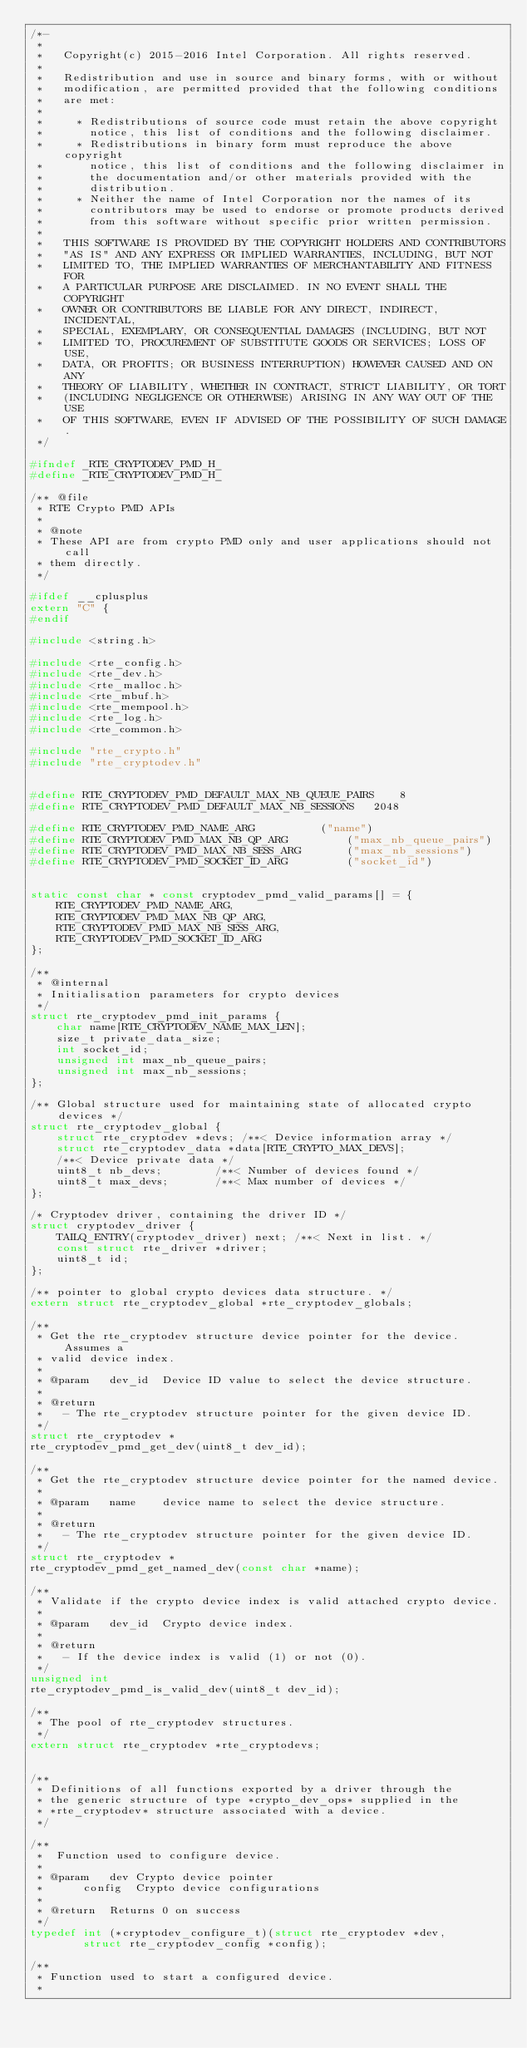Convert code to text. <code><loc_0><loc_0><loc_500><loc_500><_C_>/*-
 *
 *   Copyright(c) 2015-2016 Intel Corporation. All rights reserved.
 *
 *   Redistribution and use in source and binary forms, with or without
 *   modification, are permitted provided that the following conditions
 *   are met:
 *
 *     * Redistributions of source code must retain the above copyright
 *       notice, this list of conditions and the following disclaimer.
 *     * Redistributions in binary form must reproduce the above copyright
 *       notice, this list of conditions and the following disclaimer in
 *       the documentation and/or other materials provided with the
 *       distribution.
 *     * Neither the name of Intel Corporation nor the names of its
 *       contributors may be used to endorse or promote products derived
 *       from this software without specific prior written permission.
 *
 *   THIS SOFTWARE IS PROVIDED BY THE COPYRIGHT HOLDERS AND CONTRIBUTORS
 *   "AS IS" AND ANY EXPRESS OR IMPLIED WARRANTIES, INCLUDING, BUT NOT
 *   LIMITED TO, THE IMPLIED WARRANTIES OF MERCHANTABILITY AND FITNESS FOR
 *   A PARTICULAR PURPOSE ARE DISCLAIMED. IN NO EVENT SHALL THE COPYRIGHT
 *   OWNER OR CONTRIBUTORS BE LIABLE FOR ANY DIRECT, INDIRECT, INCIDENTAL,
 *   SPECIAL, EXEMPLARY, OR CONSEQUENTIAL DAMAGES (INCLUDING, BUT NOT
 *   LIMITED TO, PROCUREMENT OF SUBSTITUTE GOODS OR SERVICES; LOSS OF USE,
 *   DATA, OR PROFITS; OR BUSINESS INTERRUPTION) HOWEVER CAUSED AND ON ANY
 *   THEORY OF LIABILITY, WHETHER IN CONTRACT, STRICT LIABILITY, OR TORT
 *   (INCLUDING NEGLIGENCE OR OTHERWISE) ARISING IN ANY WAY OUT OF THE USE
 *   OF THIS SOFTWARE, EVEN IF ADVISED OF THE POSSIBILITY OF SUCH DAMAGE.
 */

#ifndef _RTE_CRYPTODEV_PMD_H_
#define _RTE_CRYPTODEV_PMD_H_

/** @file
 * RTE Crypto PMD APIs
 *
 * @note
 * These API are from crypto PMD only and user applications should not call
 * them directly.
 */

#ifdef __cplusplus
extern "C" {
#endif

#include <string.h>

#include <rte_config.h>
#include <rte_dev.h>
#include <rte_malloc.h>
#include <rte_mbuf.h>
#include <rte_mempool.h>
#include <rte_log.h>
#include <rte_common.h>

#include "rte_crypto.h"
#include "rte_cryptodev.h"


#define RTE_CRYPTODEV_PMD_DEFAULT_MAX_NB_QUEUE_PAIRS	8
#define RTE_CRYPTODEV_PMD_DEFAULT_MAX_NB_SESSIONS	2048

#define RTE_CRYPTODEV_PMD_NAME_ARG			("name")
#define RTE_CRYPTODEV_PMD_MAX_NB_QP_ARG			("max_nb_queue_pairs")
#define RTE_CRYPTODEV_PMD_MAX_NB_SESS_ARG		("max_nb_sessions")
#define RTE_CRYPTODEV_PMD_SOCKET_ID_ARG			("socket_id")


static const char * const cryptodev_pmd_valid_params[] = {
	RTE_CRYPTODEV_PMD_NAME_ARG,
	RTE_CRYPTODEV_PMD_MAX_NB_QP_ARG,
	RTE_CRYPTODEV_PMD_MAX_NB_SESS_ARG,
	RTE_CRYPTODEV_PMD_SOCKET_ID_ARG
};

/**
 * @internal
 * Initialisation parameters for crypto devices
 */
struct rte_cryptodev_pmd_init_params {
	char name[RTE_CRYPTODEV_NAME_MAX_LEN];
	size_t private_data_size;
	int socket_id;
	unsigned int max_nb_queue_pairs;
	unsigned int max_nb_sessions;
};

/** Global structure used for maintaining state of allocated crypto devices */
struct rte_cryptodev_global {
	struct rte_cryptodev *devs;	/**< Device information array */
	struct rte_cryptodev_data *data[RTE_CRYPTO_MAX_DEVS];
	/**< Device private data */
	uint8_t nb_devs;		/**< Number of devices found */
	uint8_t max_devs;		/**< Max number of devices */
};

/* Cryptodev driver, containing the driver ID */
struct cryptodev_driver {
	TAILQ_ENTRY(cryptodev_driver) next; /**< Next in list. */
	const struct rte_driver *driver;
	uint8_t id;
};

/** pointer to global crypto devices data structure. */
extern struct rte_cryptodev_global *rte_cryptodev_globals;

/**
 * Get the rte_cryptodev structure device pointer for the device. Assumes a
 * valid device index.
 *
 * @param	dev_id	Device ID value to select the device structure.
 *
 * @return
 *   - The rte_cryptodev structure pointer for the given device ID.
 */
struct rte_cryptodev *
rte_cryptodev_pmd_get_dev(uint8_t dev_id);

/**
 * Get the rte_cryptodev structure device pointer for the named device.
 *
 * @param	name	device name to select the device structure.
 *
 * @return
 *   - The rte_cryptodev structure pointer for the given device ID.
 */
struct rte_cryptodev *
rte_cryptodev_pmd_get_named_dev(const char *name);

/**
 * Validate if the crypto device index is valid attached crypto device.
 *
 * @param	dev_id	Crypto device index.
 *
 * @return
 *   - If the device index is valid (1) or not (0).
 */
unsigned int
rte_cryptodev_pmd_is_valid_dev(uint8_t dev_id);

/**
 * The pool of rte_cryptodev structures.
 */
extern struct rte_cryptodev *rte_cryptodevs;


/**
 * Definitions of all functions exported by a driver through the
 * the generic structure of type *crypto_dev_ops* supplied in the
 * *rte_cryptodev* structure associated with a device.
 */

/**
 *	Function used to configure device.
 *
 * @param	dev	Crypto device pointer
 *		config	Crypto device configurations
 *
 * @return	Returns 0 on success
 */
typedef int (*cryptodev_configure_t)(struct rte_cryptodev *dev,
		struct rte_cryptodev_config *config);

/**
 * Function used to start a configured device.
 *</code> 